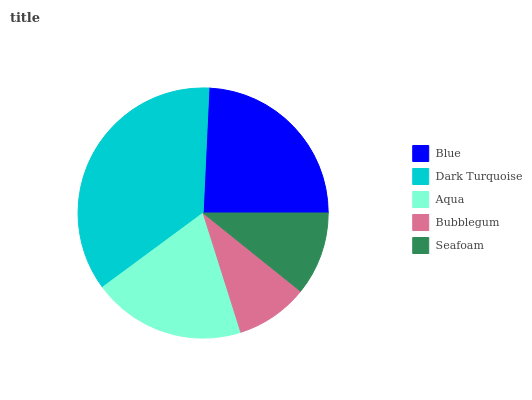Is Bubblegum the minimum?
Answer yes or no. Yes. Is Dark Turquoise the maximum?
Answer yes or no. Yes. Is Aqua the minimum?
Answer yes or no. No. Is Aqua the maximum?
Answer yes or no. No. Is Dark Turquoise greater than Aqua?
Answer yes or no. Yes. Is Aqua less than Dark Turquoise?
Answer yes or no. Yes. Is Aqua greater than Dark Turquoise?
Answer yes or no. No. Is Dark Turquoise less than Aqua?
Answer yes or no. No. Is Aqua the high median?
Answer yes or no. Yes. Is Aqua the low median?
Answer yes or no. Yes. Is Seafoam the high median?
Answer yes or no. No. Is Seafoam the low median?
Answer yes or no. No. 